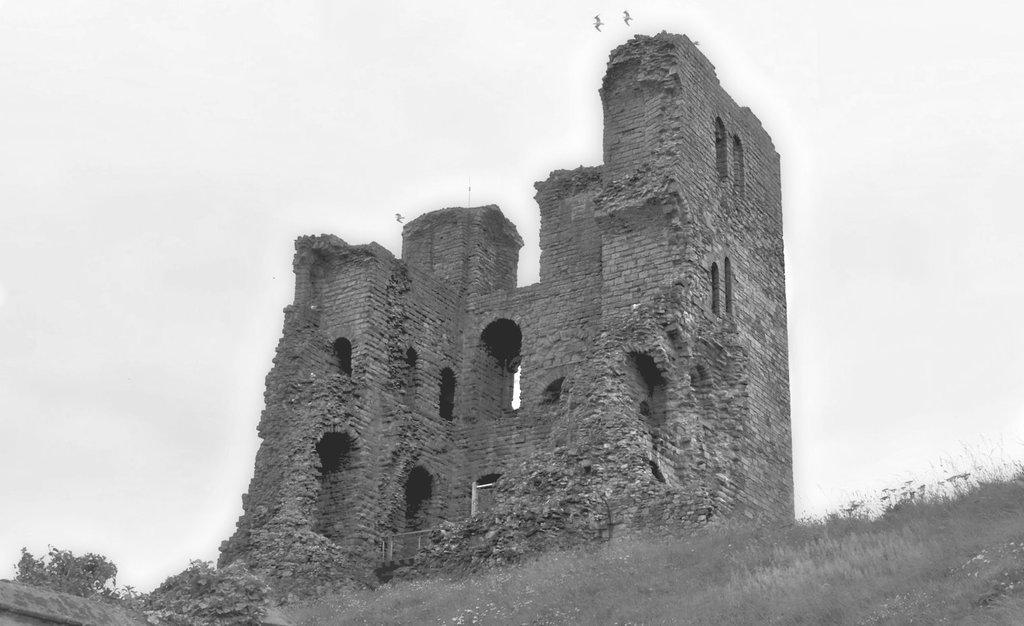Describe this image in one or two sentences. In the foreground of the image we can see the grass. In the middle of the image we can see the fort. On the top of the image we can see the sky and two birds. 